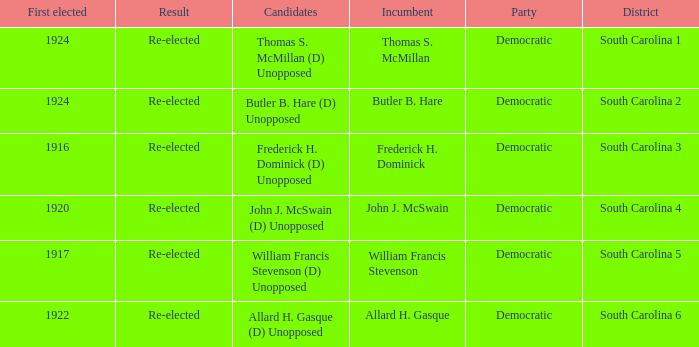What is the total number of results where the district is south carolina 5? 1.0. 